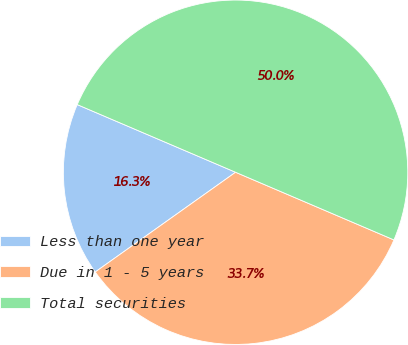Convert chart to OTSL. <chart><loc_0><loc_0><loc_500><loc_500><pie_chart><fcel>Less than one year<fcel>Due in 1 - 5 years<fcel>Total securities<nl><fcel>16.26%<fcel>33.74%<fcel>50.0%<nl></chart> 